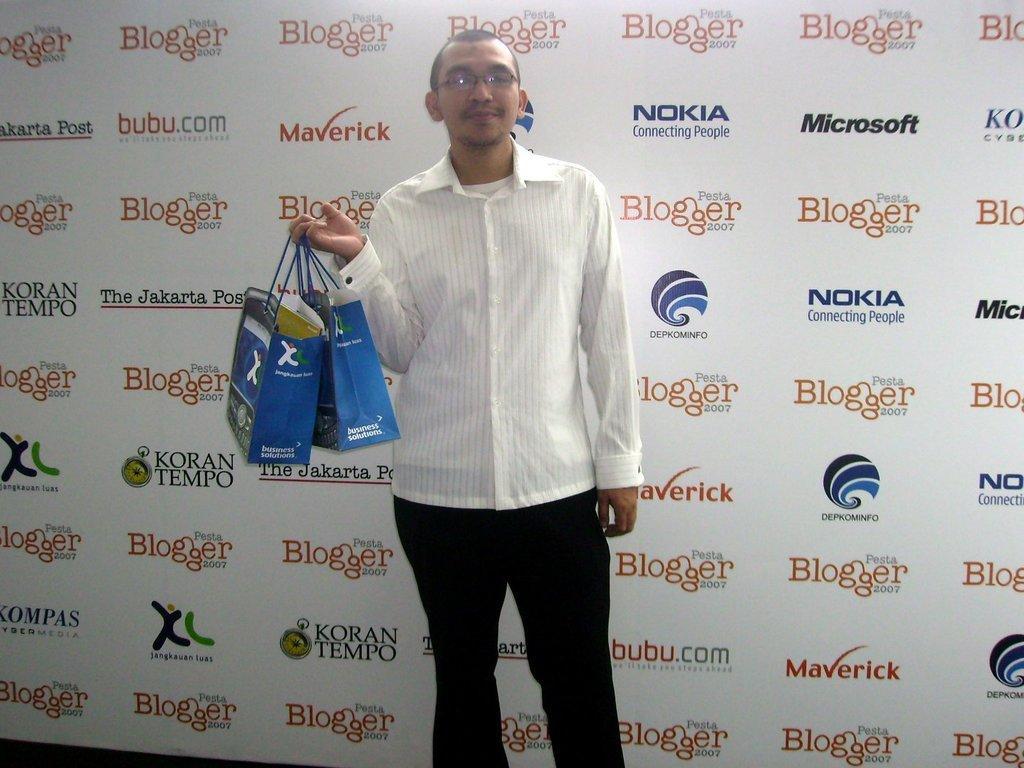Could you give a brief overview of what you see in this image? In this image in the center there is one person who is standing and he is holding some bags, in the background there is a board and on the board there is some text. 